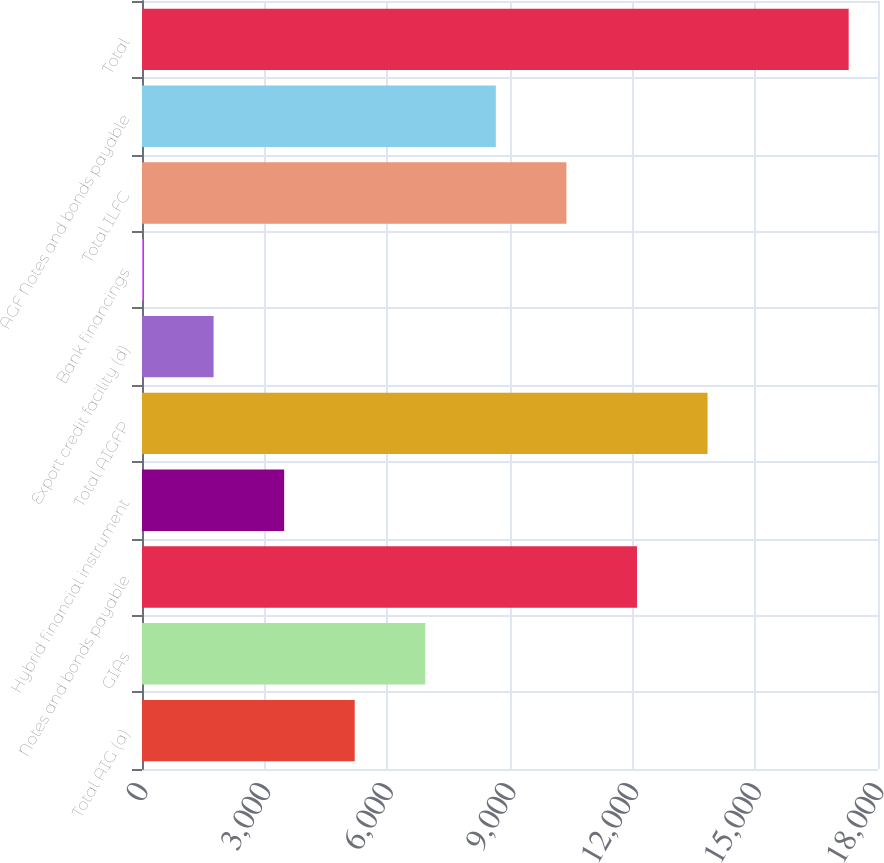Convert chart to OTSL. <chart><loc_0><loc_0><loc_500><loc_500><bar_chart><fcel>Total AIG (a)<fcel>GIAs<fcel>Notes and bonds payable<fcel>Hybrid financial instrument<fcel>Total AIGFP<fcel>Export credit facility (d)<fcel>Bank financings<fcel>Total ILFC<fcel>AGF Notes and bonds payable<fcel>Total<nl><fcel>5202.4<fcel>6928.2<fcel>12105.6<fcel>3476.6<fcel>13831.4<fcel>1750.8<fcel>25<fcel>10379.8<fcel>8654<fcel>17283<nl></chart> 